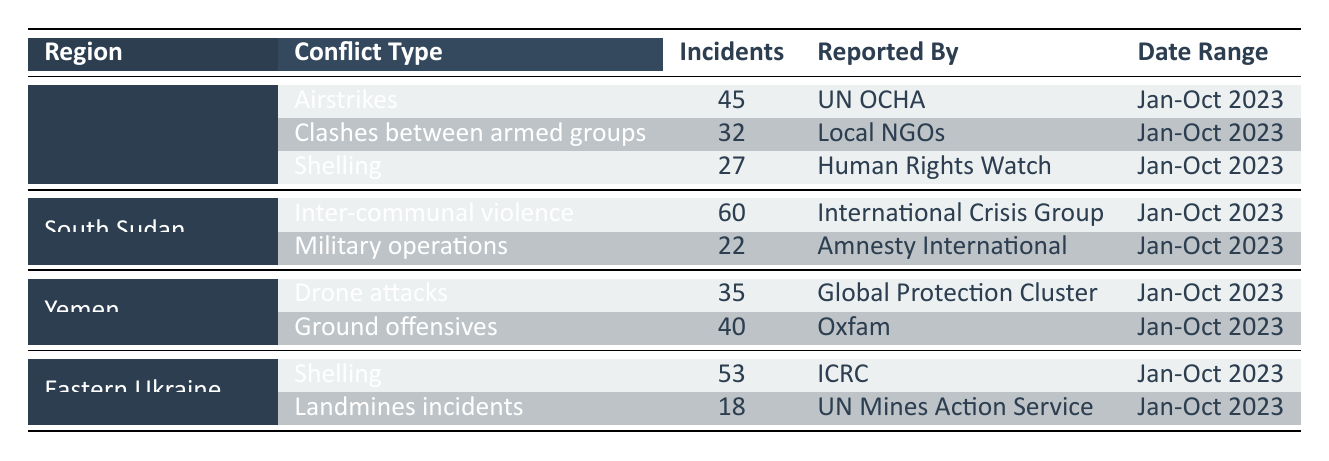What is the total number of incidents reported in Northwestern Syria? In Northwestern Syria, there are three types of conflicts: Airstrikes (45), Clashes between armed groups (32), and Shelling (27). Summing these incidents gives 45 + 32 + 27 = 104.
Answer: 104 Which region reported the highest number of conflict incidents? The incidents reported by region are: Northwestern Syria (104), South Sudan (82), Yemen (75), and Eastern Ukraine (71). Comparing these totals, Northwestern Syria has the highest number with 104 incidents.
Answer: Northwestern Syria How many incidents of inter-communal violence were reported in South Sudan? South Sudan reported 60 incidents of inter-communal violence as indicated in the table.
Answer: 60 Is there any region that reported military operations? The table shows that South Sudan has reported military operations with an incident count of 22. Since this is yes, the answer is true.
Answer: Yes What is the average number of incidents for conflict types in Yemen? Yemen has two types of reported conflicts: Drone attacks (35) and Ground offensives (40). To find the average, we sum the incidents (35 + 40 = 75) and divide by the number of conflict types (2). So, the average is 75/2 = 37.5.
Answer: 37.5 What is the difference in the number of incidents between Airstrikes in Northwestern Syria and Drone attacks in Yemen? The number of Airstrikes incidents is 45 and the number of Drone attack incidents is 35. To find the difference, we subtract the two values: 45 - 35 = 10.
Answer: 10 Which reporting organization recorded the highest number of incidents in a single type of conflict? The highest number of incidents for a single type of conflict is found in South Sudan with 60 incidents of inter-communal violence reported by the International Crisis Group. Therefore, they recorded the highest.
Answer: International Crisis Group How many incidents were reported in Eastern Ukraine? In Eastern Ukraine, there are two conflict types: Shelling (53) and Landmines incidents (18). Adding these gives 53 + 18 = 71.
Answer: 71 Was there a report of clashes between armed groups in South Sudan? The table indicates that clashes between armed groups are reported only in Northwestern Syria, not in South Sudan. Therefore, the answer is false.
Answer: No 